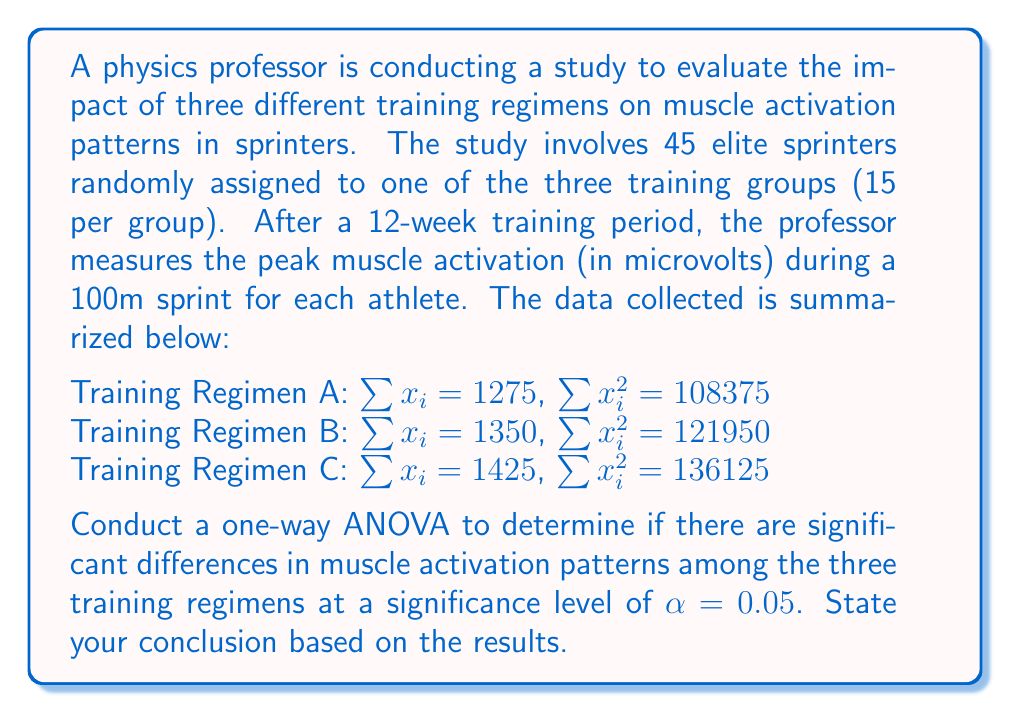Can you solve this math problem? To conduct a one-way ANOVA, we need to follow these steps:

1. Calculate the sum of squares total (SST), sum of squares between (SSB), and sum of squares within (SSW).
2. Calculate the degrees of freedom for between groups (dfB) and within groups (dfW).
3. Calculate the mean square between (MSB) and mean square within (MSW).
4. Calculate the F-statistic.
5. Compare the F-statistic to the critical F-value.

Step 1: Calculate SST, SSB, and SSW

First, we need to calculate the total sum of squares (SST):

$SST = \sum_{i=1}^{3}\sum_{j=1}^{15} x_{ij}^2 - \frac{(\sum_{i=1}^{3}\sum_{j=1}^{15} x_{ij})^2}{N}$

$SST = (108375 + 121950 + 136125) - \frac{(1275 + 1350 + 1425)^2}{45}$

$SST = 366450 - \frac{4050^2}{45} = 366450 - 364500 = 1950$

Now, let's calculate the sum of squares between groups (SSB):

$SSB = \sum_{i=1}^{3} \frac{(\sum_{j=1}^{15} x_{ij})^2}{n_i} - \frac{(\sum_{i=1}^{3}\sum_{j=1}^{15} x_{ij})^2}{N}$

$SSB = \frac{1275^2 + 1350^2 + 1425^2}{15} - \frac{4050^2}{45}$

$SSB = 365850 - 364500 = 1350$

The sum of squares within groups (SSW) is the difference between SST and SSB:

$SSW = SST - SSB = 1950 - 1350 = 600$

Step 2: Calculate degrees of freedom

$df_B = k - 1 = 3 - 1 = 2$ (where k is the number of groups)
$df_W = N - k = 45 - 3 = 42$

Step 3: Calculate mean squares

$MSB = \frac{SSB}{df_B} = \frac{1350}{2} = 675$
$MSW = \frac{SSW}{df_W} = \frac{600}{42} \approx 14.29$

Step 4: Calculate F-statistic

$F = \frac{MSB}{MSW} = \frac{675}{14.29} \approx 47.24$

Step 5: Compare F-statistic to critical F-value

The critical F-value for $\alpha = 0.05$, $df_B = 2$, and $df_W = 42$ is approximately 3.22 (from F-distribution table).

Since our calculated F-statistic (47.24) is greater than the critical F-value (3.22), we reject the null hypothesis.
Answer: The one-way ANOVA results show a significant difference in muscle activation patterns among the three training regimens (F(2, 42) ≈ 47.24, p < 0.05). We reject the null hypothesis and conclude that at least one of the training regimens has a significantly different effect on muscle activation patterns in sprinters. 